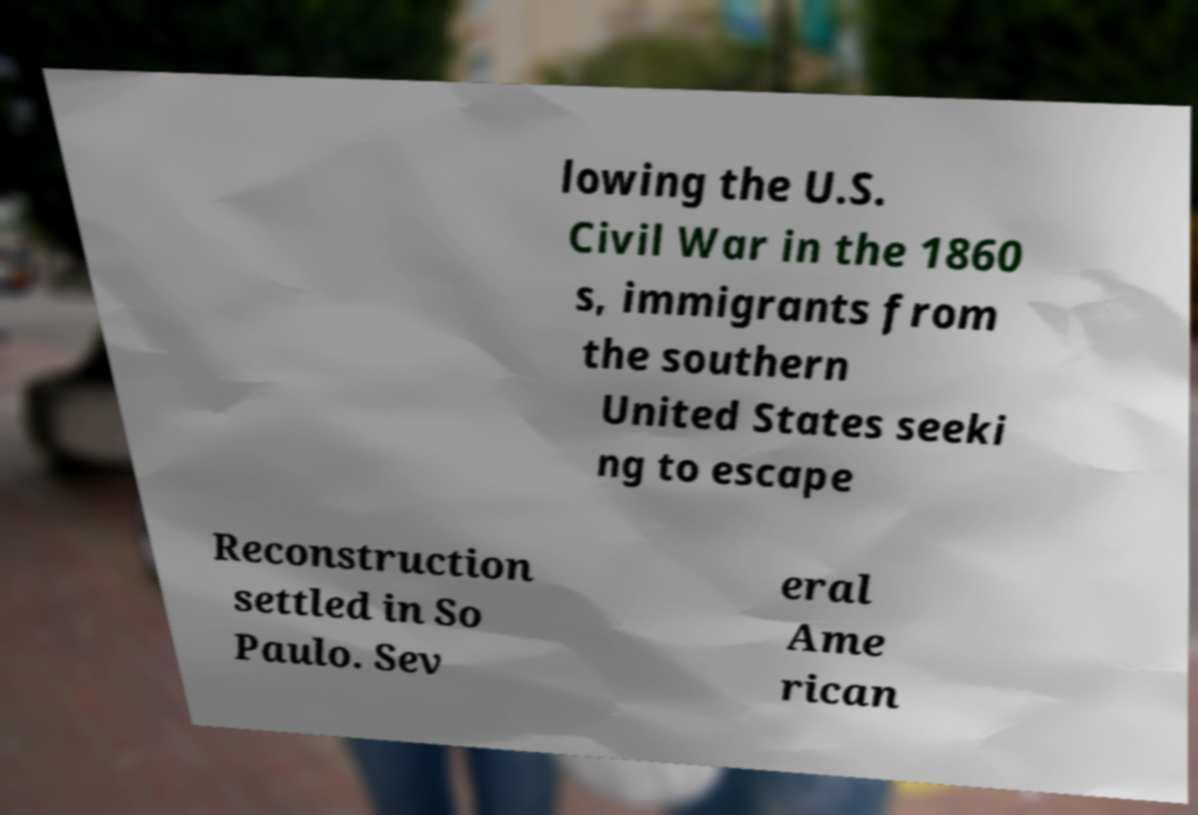I need the written content from this picture converted into text. Can you do that? lowing the U.S. Civil War in the 1860 s, immigrants from the southern United States seeki ng to escape Reconstruction settled in So Paulo. Sev eral Ame rican 